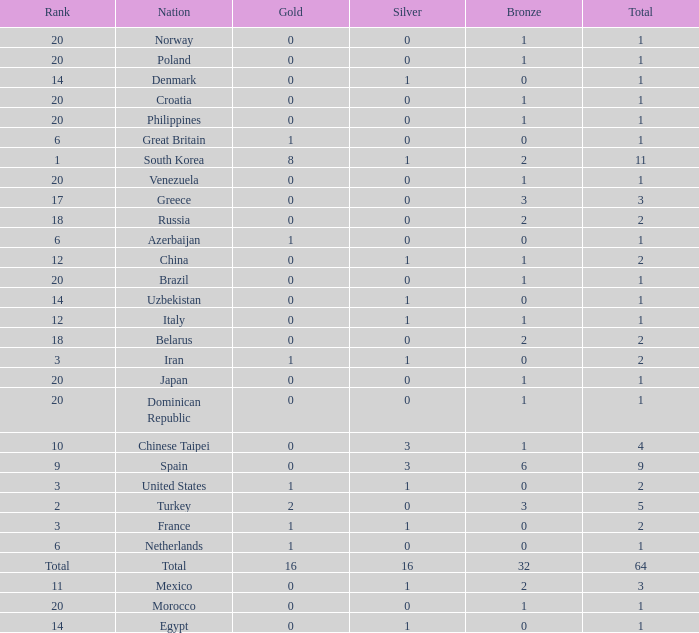What is the lowest number of gold medals the nation with less than 0 silver medals has? None. 